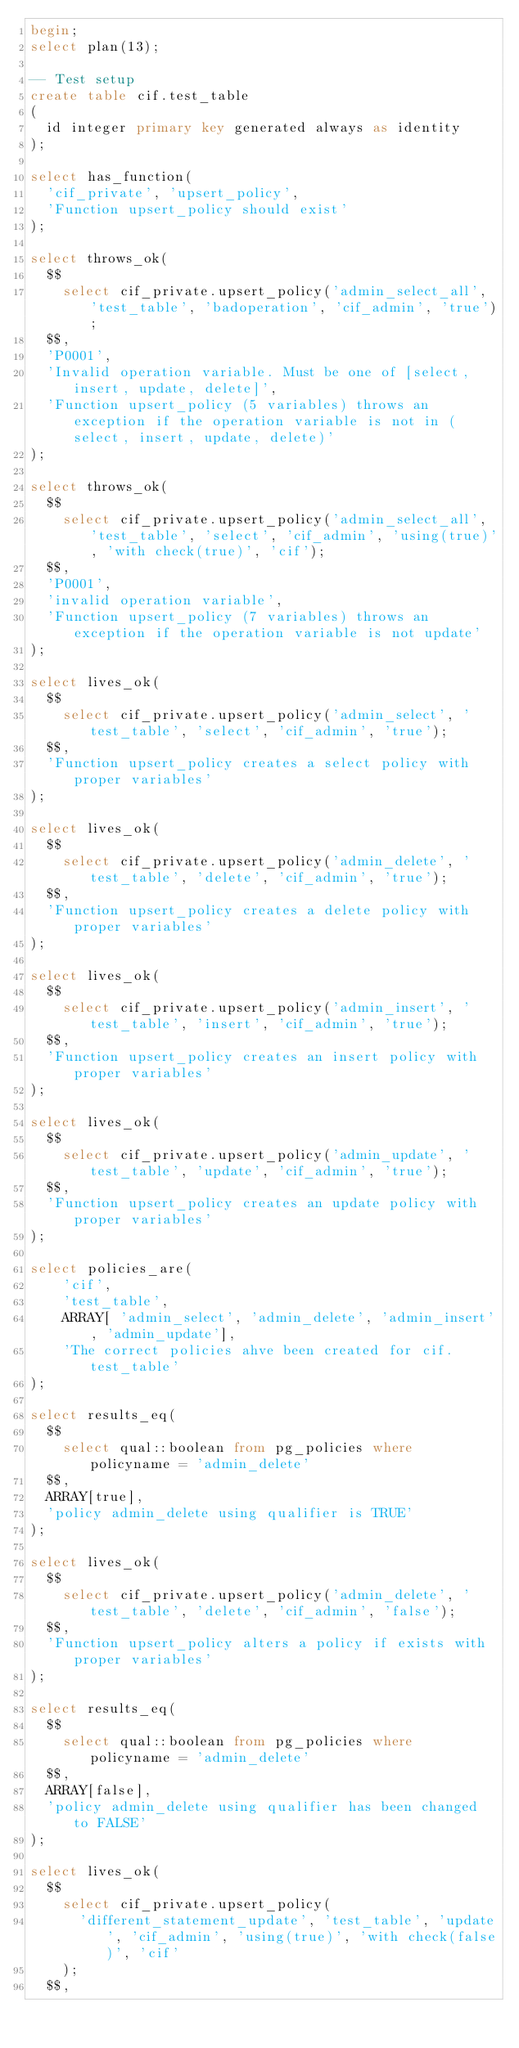<code> <loc_0><loc_0><loc_500><loc_500><_SQL_>begin;
select plan(13);

-- Test setup
create table cif.test_table
(
  id integer primary key generated always as identity
);

select has_function(
  'cif_private', 'upsert_policy',
  'Function upsert_policy should exist'
);

select throws_ok(
  $$
    select cif_private.upsert_policy('admin_select_all', 'test_table', 'badoperation', 'cif_admin', 'true');
  $$,
  'P0001',
  'Invalid operation variable. Must be one of [select, insert, update, delete]',
  'Function upsert_policy (5 variables) throws an exception if the operation variable is not in (select, insert, update, delete)'
);

select throws_ok(
  $$
    select cif_private.upsert_policy('admin_select_all', 'test_table', 'select', 'cif_admin', 'using(true)', 'with check(true)', 'cif');
  $$,
  'P0001',
  'invalid operation variable',
  'Function upsert_policy (7 variables) throws an exception if the operation variable is not update'
);

select lives_ok(
  $$
    select cif_private.upsert_policy('admin_select', 'test_table', 'select', 'cif_admin', 'true');
  $$,
  'Function upsert_policy creates a select policy with proper variables'
);

select lives_ok(
  $$
    select cif_private.upsert_policy('admin_delete', 'test_table', 'delete', 'cif_admin', 'true');
  $$,
  'Function upsert_policy creates a delete policy with proper variables'
);

select lives_ok(
  $$
    select cif_private.upsert_policy('admin_insert', 'test_table', 'insert', 'cif_admin', 'true');
  $$,
  'Function upsert_policy creates an insert policy with proper variables'
);

select lives_ok(
  $$
    select cif_private.upsert_policy('admin_update', 'test_table', 'update', 'cif_admin', 'true');
  $$,
  'Function upsert_policy creates an update policy with proper variables'
);

select policies_are(
    'cif',
    'test_table',
    ARRAY[ 'admin_select', 'admin_delete', 'admin_insert', 'admin_update'],
    'The correct policies ahve been created for cif.test_table'
);

select results_eq(
  $$
    select qual::boolean from pg_policies where policyname = 'admin_delete'
  $$,
  ARRAY[true],
  'policy admin_delete using qualifier is TRUE'
);

select lives_ok(
  $$
    select cif_private.upsert_policy('admin_delete', 'test_table', 'delete', 'cif_admin', 'false');
  $$,
  'Function upsert_policy alters a policy if exists with proper variables'
);

select results_eq(
  $$
    select qual::boolean from pg_policies where policyname = 'admin_delete'
  $$,
  ARRAY[false],
  'policy admin_delete using qualifier has been changed to FALSE'
);

select lives_ok(
  $$
    select cif_private.upsert_policy(
      'different_statement_update', 'test_table', 'update', 'cif_admin', 'using(true)', 'with check(false)', 'cif'
    );
  $$,</code> 